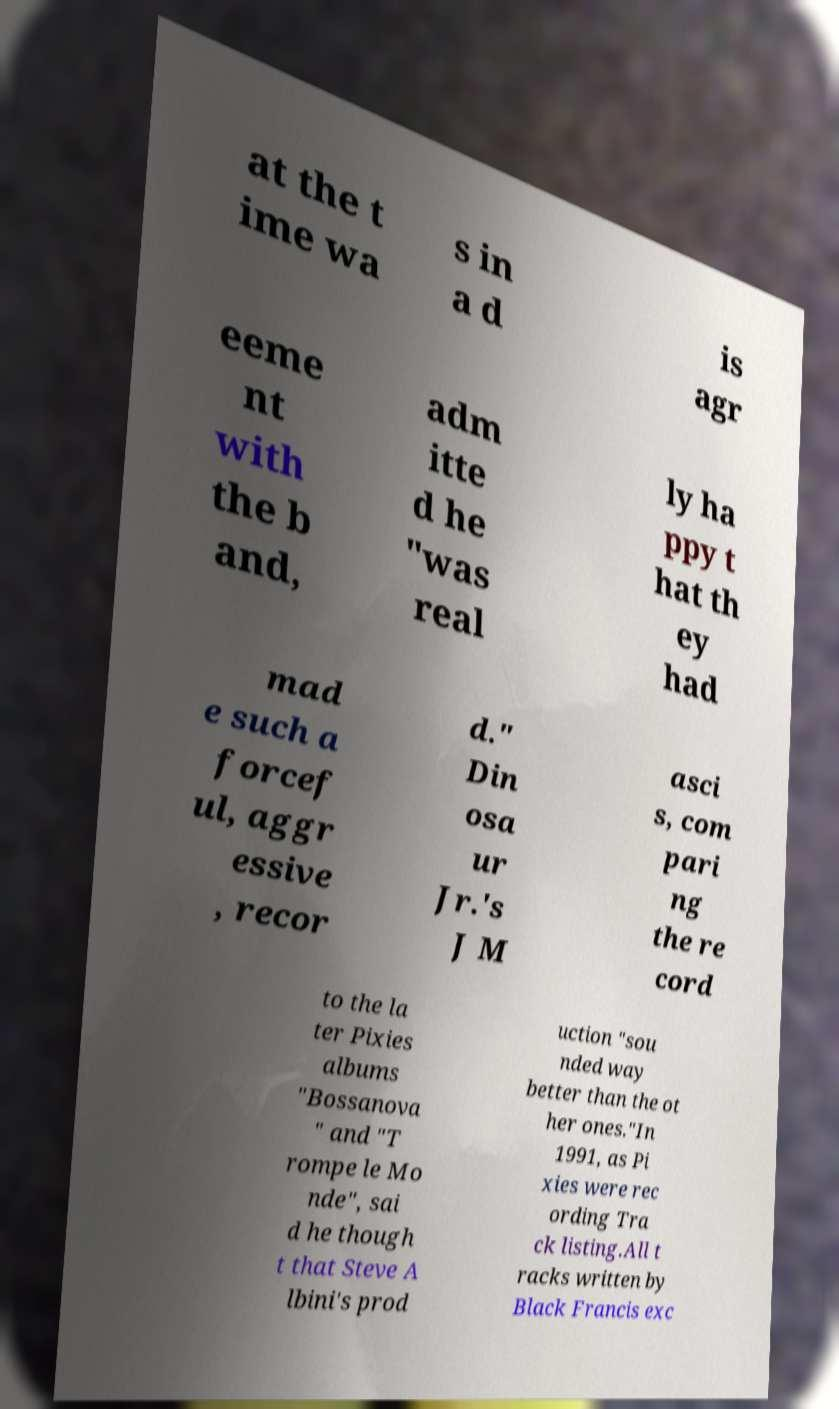Please read and relay the text visible in this image. What does it say? at the t ime wa s in a d is agr eeme nt with the b and, adm itte d he "was real ly ha ppy t hat th ey had mad e such a forcef ul, aggr essive , recor d." Din osa ur Jr.'s J M asci s, com pari ng the re cord to the la ter Pixies albums "Bossanova " and "T rompe le Mo nde", sai d he though t that Steve A lbini's prod uction "sou nded way better than the ot her ones."In 1991, as Pi xies were rec ording Tra ck listing.All t racks written by Black Francis exc 